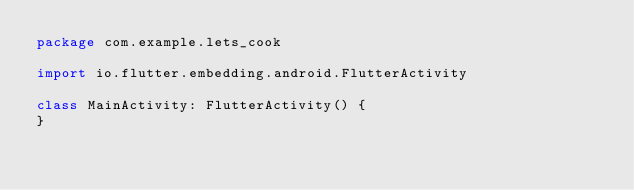Convert code to text. <code><loc_0><loc_0><loc_500><loc_500><_Kotlin_>package com.example.lets_cook

import io.flutter.embedding.android.FlutterActivity

class MainActivity: FlutterActivity() {
}
</code> 